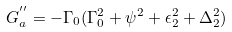<formula> <loc_0><loc_0><loc_500><loc_500>G ^ { ^ { \prime \prime } } _ { a } = - \Gamma _ { 0 } ( \Gamma _ { 0 } ^ { 2 } + \psi ^ { 2 } + \epsilon _ { 2 } ^ { 2 } + \Delta _ { 2 } ^ { 2 } )</formula> 